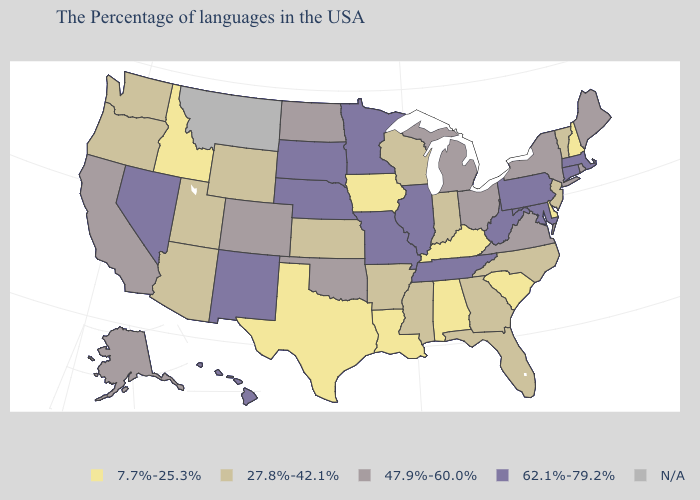Name the states that have a value in the range N/A?
Quick response, please. Montana. Name the states that have a value in the range 47.9%-60.0%?
Write a very short answer. Maine, Rhode Island, New York, Virginia, Ohio, Michigan, Oklahoma, North Dakota, Colorado, California, Alaska. Which states hav the highest value in the West?
Concise answer only. New Mexico, Nevada, Hawaii. Which states hav the highest value in the MidWest?
Be succinct. Illinois, Missouri, Minnesota, Nebraska, South Dakota. What is the value of Arizona?
Write a very short answer. 27.8%-42.1%. How many symbols are there in the legend?
Keep it brief. 5. What is the value of Nebraska?
Be succinct. 62.1%-79.2%. Name the states that have a value in the range 62.1%-79.2%?
Short answer required. Massachusetts, Connecticut, Maryland, Pennsylvania, West Virginia, Tennessee, Illinois, Missouri, Minnesota, Nebraska, South Dakota, New Mexico, Nevada, Hawaii. What is the highest value in the USA?
Keep it brief. 62.1%-79.2%. What is the value of Vermont?
Concise answer only. 27.8%-42.1%. Does Iowa have the lowest value in the MidWest?
Keep it brief. Yes. Name the states that have a value in the range 27.8%-42.1%?
Give a very brief answer. Vermont, New Jersey, North Carolina, Florida, Georgia, Indiana, Wisconsin, Mississippi, Arkansas, Kansas, Wyoming, Utah, Arizona, Washington, Oregon. What is the value of Virginia?
Answer briefly. 47.9%-60.0%. What is the value of Ohio?
Answer briefly. 47.9%-60.0%. 